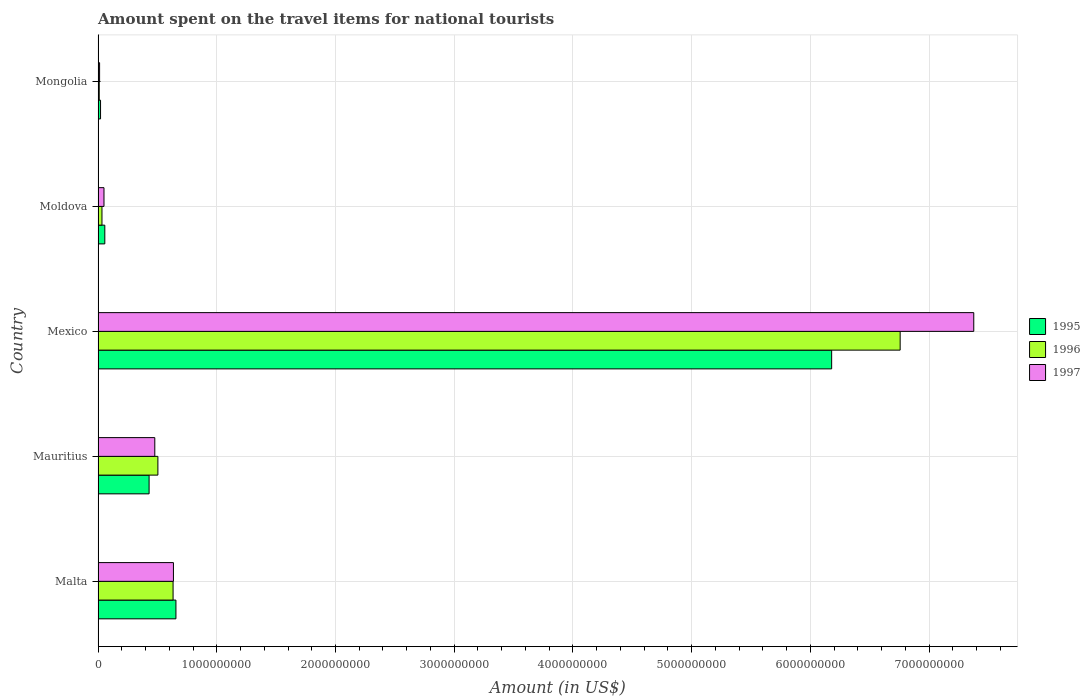How many different coloured bars are there?
Offer a very short reply. 3. How many bars are there on the 5th tick from the top?
Your response must be concise. 3. How many bars are there on the 4th tick from the bottom?
Ensure brevity in your answer.  3. In how many cases, is the number of bars for a given country not equal to the number of legend labels?
Your answer should be compact. 0. Across all countries, what is the maximum amount spent on the travel items for national tourists in 1996?
Your answer should be very brief. 6.76e+09. Across all countries, what is the minimum amount spent on the travel items for national tourists in 1995?
Your answer should be very brief. 2.10e+07. In which country was the amount spent on the travel items for national tourists in 1996 maximum?
Keep it short and to the point. Mexico. In which country was the amount spent on the travel items for national tourists in 1997 minimum?
Provide a succinct answer. Mongolia. What is the total amount spent on the travel items for national tourists in 1996 in the graph?
Give a very brief answer. 7.94e+09. What is the difference between the amount spent on the travel items for national tourists in 1996 in Mexico and that in Moldova?
Provide a short and direct response. 6.72e+09. What is the difference between the amount spent on the travel items for national tourists in 1995 in Mongolia and the amount spent on the travel items for national tourists in 1997 in Mexico?
Your answer should be compact. -7.36e+09. What is the average amount spent on the travel items for national tourists in 1995 per country?
Provide a succinct answer. 1.47e+09. What is the difference between the amount spent on the travel items for national tourists in 1996 and amount spent on the travel items for national tourists in 1997 in Malta?
Ensure brevity in your answer.  -3.00e+06. What is the ratio of the amount spent on the travel items for national tourists in 1995 in Malta to that in Moldova?
Give a very brief answer. 11.51. Is the amount spent on the travel items for national tourists in 1995 in Mexico less than that in Mongolia?
Provide a succinct answer. No. Is the difference between the amount spent on the travel items for national tourists in 1996 in Mexico and Moldova greater than the difference between the amount spent on the travel items for national tourists in 1997 in Mexico and Moldova?
Offer a very short reply. No. What is the difference between the highest and the second highest amount spent on the travel items for national tourists in 1995?
Offer a very short reply. 5.52e+09. What is the difference between the highest and the lowest amount spent on the travel items for national tourists in 1995?
Your answer should be compact. 6.16e+09. What does the 1st bar from the top in Mauritius represents?
Your answer should be very brief. 1997. What does the 3rd bar from the bottom in Moldova represents?
Offer a very short reply. 1997. Is it the case that in every country, the sum of the amount spent on the travel items for national tourists in 1997 and amount spent on the travel items for national tourists in 1995 is greater than the amount spent on the travel items for national tourists in 1996?
Give a very brief answer. Yes. Are all the bars in the graph horizontal?
Offer a terse response. Yes. What is the difference between two consecutive major ticks on the X-axis?
Keep it short and to the point. 1.00e+09. Does the graph contain grids?
Your response must be concise. Yes. How many legend labels are there?
Your response must be concise. 3. How are the legend labels stacked?
Your response must be concise. Vertical. What is the title of the graph?
Offer a terse response. Amount spent on the travel items for national tourists. What is the label or title of the X-axis?
Your answer should be compact. Amount (in US$). What is the Amount (in US$) in 1995 in Malta?
Keep it short and to the point. 6.56e+08. What is the Amount (in US$) of 1996 in Malta?
Offer a very short reply. 6.32e+08. What is the Amount (in US$) of 1997 in Malta?
Ensure brevity in your answer.  6.35e+08. What is the Amount (in US$) in 1995 in Mauritius?
Offer a terse response. 4.30e+08. What is the Amount (in US$) in 1996 in Mauritius?
Keep it short and to the point. 5.04e+08. What is the Amount (in US$) of 1997 in Mauritius?
Your response must be concise. 4.78e+08. What is the Amount (in US$) of 1995 in Mexico?
Keep it short and to the point. 6.18e+09. What is the Amount (in US$) in 1996 in Mexico?
Provide a succinct answer. 6.76e+09. What is the Amount (in US$) in 1997 in Mexico?
Provide a short and direct response. 7.38e+09. What is the Amount (in US$) of 1995 in Moldova?
Your answer should be very brief. 5.70e+07. What is the Amount (in US$) of 1996 in Moldova?
Ensure brevity in your answer.  3.30e+07. What is the Amount (in US$) of 1997 in Moldova?
Your answer should be very brief. 5.00e+07. What is the Amount (in US$) of 1995 in Mongolia?
Your response must be concise. 2.10e+07. What is the Amount (in US$) of 1997 in Mongolia?
Ensure brevity in your answer.  1.30e+07. Across all countries, what is the maximum Amount (in US$) in 1995?
Provide a short and direct response. 6.18e+09. Across all countries, what is the maximum Amount (in US$) of 1996?
Offer a terse response. 6.76e+09. Across all countries, what is the maximum Amount (in US$) of 1997?
Ensure brevity in your answer.  7.38e+09. Across all countries, what is the minimum Amount (in US$) of 1995?
Your answer should be compact. 2.10e+07. Across all countries, what is the minimum Amount (in US$) of 1996?
Your response must be concise. 1.00e+07. Across all countries, what is the minimum Amount (in US$) in 1997?
Offer a very short reply. 1.30e+07. What is the total Amount (in US$) in 1995 in the graph?
Keep it short and to the point. 7.34e+09. What is the total Amount (in US$) in 1996 in the graph?
Provide a succinct answer. 7.94e+09. What is the total Amount (in US$) in 1997 in the graph?
Give a very brief answer. 8.55e+09. What is the difference between the Amount (in US$) of 1995 in Malta and that in Mauritius?
Make the answer very short. 2.26e+08. What is the difference between the Amount (in US$) in 1996 in Malta and that in Mauritius?
Your response must be concise. 1.28e+08. What is the difference between the Amount (in US$) in 1997 in Malta and that in Mauritius?
Provide a short and direct response. 1.57e+08. What is the difference between the Amount (in US$) of 1995 in Malta and that in Mexico?
Keep it short and to the point. -5.52e+09. What is the difference between the Amount (in US$) of 1996 in Malta and that in Mexico?
Give a very brief answer. -6.12e+09. What is the difference between the Amount (in US$) of 1997 in Malta and that in Mexico?
Provide a succinct answer. -6.74e+09. What is the difference between the Amount (in US$) of 1995 in Malta and that in Moldova?
Provide a short and direct response. 5.99e+08. What is the difference between the Amount (in US$) of 1996 in Malta and that in Moldova?
Keep it short and to the point. 5.99e+08. What is the difference between the Amount (in US$) of 1997 in Malta and that in Moldova?
Offer a very short reply. 5.85e+08. What is the difference between the Amount (in US$) of 1995 in Malta and that in Mongolia?
Give a very brief answer. 6.35e+08. What is the difference between the Amount (in US$) of 1996 in Malta and that in Mongolia?
Your answer should be very brief. 6.22e+08. What is the difference between the Amount (in US$) in 1997 in Malta and that in Mongolia?
Offer a very short reply. 6.22e+08. What is the difference between the Amount (in US$) of 1995 in Mauritius and that in Mexico?
Give a very brief answer. -5.75e+09. What is the difference between the Amount (in US$) in 1996 in Mauritius and that in Mexico?
Your answer should be very brief. -6.25e+09. What is the difference between the Amount (in US$) of 1997 in Mauritius and that in Mexico?
Your answer should be very brief. -6.90e+09. What is the difference between the Amount (in US$) in 1995 in Mauritius and that in Moldova?
Make the answer very short. 3.73e+08. What is the difference between the Amount (in US$) of 1996 in Mauritius and that in Moldova?
Give a very brief answer. 4.71e+08. What is the difference between the Amount (in US$) of 1997 in Mauritius and that in Moldova?
Provide a succinct answer. 4.28e+08. What is the difference between the Amount (in US$) in 1995 in Mauritius and that in Mongolia?
Your answer should be compact. 4.09e+08. What is the difference between the Amount (in US$) in 1996 in Mauritius and that in Mongolia?
Offer a terse response. 4.94e+08. What is the difference between the Amount (in US$) of 1997 in Mauritius and that in Mongolia?
Keep it short and to the point. 4.65e+08. What is the difference between the Amount (in US$) of 1995 in Mexico and that in Moldova?
Provide a short and direct response. 6.12e+09. What is the difference between the Amount (in US$) of 1996 in Mexico and that in Moldova?
Ensure brevity in your answer.  6.72e+09. What is the difference between the Amount (in US$) in 1997 in Mexico and that in Moldova?
Offer a very short reply. 7.33e+09. What is the difference between the Amount (in US$) of 1995 in Mexico and that in Mongolia?
Provide a short and direct response. 6.16e+09. What is the difference between the Amount (in US$) of 1996 in Mexico and that in Mongolia?
Your response must be concise. 6.75e+09. What is the difference between the Amount (in US$) in 1997 in Mexico and that in Mongolia?
Offer a very short reply. 7.36e+09. What is the difference between the Amount (in US$) in 1995 in Moldova and that in Mongolia?
Offer a very short reply. 3.60e+07. What is the difference between the Amount (in US$) in 1996 in Moldova and that in Mongolia?
Offer a very short reply. 2.30e+07. What is the difference between the Amount (in US$) of 1997 in Moldova and that in Mongolia?
Ensure brevity in your answer.  3.70e+07. What is the difference between the Amount (in US$) in 1995 in Malta and the Amount (in US$) in 1996 in Mauritius?
Ensure brevity in your answer.  1.52e+08. What is the difference between the Amount (in US$) in 1995 in Malta and the Amount (in US$) in 1997 in Mauritius?
Your answer should be very brief. 1.78e+08. What is the difference between the Amount (in US$) in 1996 in Malta and the Amount (in US$) in 1997 in Mauritius?
Give a very brief answer. 1.54e+08. What is the difference between the Amount (in US$) of 1995 in Malta and the Amount (in US$) of 1996 in Mexico?
Provide a short and direct response. -6.10e+09. What is the difference between the Amount (in US$) in 1995 in Malta and the Amount (in US$) in 1997 in Mexico?
Offer a very short reply. -6.72e+09. What is the difference between the Amount (in US$) of 1996 in Malta and the Amount (in US$) of 1997 in Mexico?
Make the answer very short. -6.74e+09. What is the difference between the Amount (in US$) in 1995 in Malta and the Amount (in US$) in 1996 in Moldova?
Give a very brief answer. 6.23e+08. What is the difference between the Amount (in US$) of 1995 in Malta and the Amount (in US$) of 1997 in Moldova?
Your answer should be compact. 6.06e+08. What is the difference between the Amount (in US$) in 1996 in Malta and the Amount (in US$) in 1997 in Moldova?
Give a very brief answer. 5.82e+08. What is the difference between the Amount (in US$) in 1995 in Malta and the Amount (in US$) in 1996 in Mongolia?
Offer a very short reply. 6.46e+08. What is the difference between the Amount (in US$) of 1995 in Malta and the Amount (in US$) of 1997 in Mongolia?
Keep it short and to the point. 6.43e+08. What is the difference between the Amount (in US$) of 1996 in Malta and the Amount (in US$) of 1997 in Mongolia?
Make the answer very short. 6.19e+08. What is the difference between the Amount (in US$) of 1995 in Mauritius and the Amount (in US$) of 1996 in Mexico?
Give a very brief answer. -6.33e+09. What is the difference between the Amount (in US$) of 1995 in Mauritius and the Amount (in US$) of 1997 in Mexico?
Offer a terse response. -6.95e+09. What is the difference between the Amount (in US$) in 1996 in Mauritius and the Amount (in US$) in 1997 in Mexico?
Your answer should be compact. -6.87e+09. What is the difference between the Amount (in US$) of 1995 in Mauritius and the Amount (in US$) of 1996 in Moldova?
Your answer should be compact. 3.97e+08. What is the difference between the Amount (in US$) in 1995 in Mauritius and the Amount (in US$) in 1997 in Moldova?
Your answer should be compact. 3.80e+08. What is the difference between the Amount (in US$) in 1996 in Mauritius and the Amount (in US$) in 1997 in Moldova?
Keep it short and to the point. 4.54e+08. What is the difference between the Amount (in US$) of 1995 in Mauritius and the Amount (in US$) of 1996 in Mongolia?
Keep it short and to the point. 4.20e+08. What is the difference between the Amount (in US$) of 1995 in Mauritius and the Amount (in US$) of 1997 in Mongolia?
Your answer should be compact. 4.17e+08. What is the difference between the Amount (in US$) in 1996 in Mauritius and the Amount (in US$) in 1997 in Mongolia?
Your answer should be very brief. 4.91e+08. What is the difference between the Amount (in US$) of 1995 in Mexico and the Amount (in US$) of 1996 in Moldova?
Make the answer very short. 6.15e+09. What is the difference between the Amount (in US$) of 1995 in Mexico and the Amount (in US$) of 1997 in Moldova?
Ensure brevity in your answer.  6.13e+09. What is the difference between the Amount (in US$) of 1996 in Mexico and the Amount (in US$) of 1997 in Moldova?
Your answer should be compact. 6.71e+09. What is the difference between the Amount (in US$) in 1995 in Mexico and the Amount (in US$) in 1996 in Mongolia?
Your answer should be compact. 6.17e+09. What is the difference between the Amount (in US$) in 1995 in Mexico and the Amount (in US$) in 1997 in Mongolia?
Give a very brief answer. 6.17e+09. What is the difference between the Amount (in US$) of 1996 in Mexico and the Amount (in US$) of 1997 in Mongolia?
Offer a terse response. 6.74e+09. What is the difference between the Amount (in US$) in 1995 in Moldova and the Amount (in US$) in 1996 in Mongolia?
Make the answer very short. 4.70e+07. What is the difference between the Amount (in US$) of 1995 in Moldova and the Amount (in US$) of 1997 in Mongolia?
Keep it short and to the point. 4.40e+07. What is the difference between the Amount (in US$) in 1996 in Moldova and the Amount (in US$) in 1997 in Mongolia?
Make the answer very short. 2.00e+07. What is the average Amount (in US$) of 1995 per country?
Keep it short and to the point. 1.47e+09. What is the average Amount (in US$) of 1996 per country?
Keep it short and to the point. 1.59e+09. What is the average Amount (in US$) of 1997 per country?
Provide a succinct answer. 1.71e+09. What is the difference between the Amount (in US$) of 1995 and Amount (in US$) of 1996 in Malta?
Offer a very short reply. 2.40e+07. What is the difference between the Amount (in US$) of 1995 and Amount (in US$) of 1997 in Malta?
Give a very brief answer. 2.10e+07. What is the difference between the Amount (in US$) of 1996 and Amount (in US$) of 1997 in Malta?
Offer a very short reply. -3.00e+06. What is the difference between the Amount (in US$) in 1995 and Amount (in US$) in 1996 in Mauritius?
Make the answer very short. -7.40e+07. What is the difference between the Amount (in US$) of 1995 and Amount (in US$) of 1997 in Mauritius?
Your answer should be very brief. -4.80e+07. What is the difference between the Amount (in US$) in 1996 and Amount (in US$) in 1997 in Mauritius?
Provide a short and direct response. 2.60e+07. What is the difference between the Amount (in US$) in 1995 and Amount (in US$) in 1996 in Mexico?
Your response must be concise. -5.77e+08. What is the difference between the Amount (in US$) in 1995 and Amount (in US$) in 1997 in Mexico?
Your response must be concise. -1.20e+09. What is the difference between the Amount (in US$) of 1996 and Amount (in US$) of 1997 in Mexico?
Offer a very short reply. -6.20e+08. What is the difference between the Amount (in US$) of 1995 and Amount (in US$) of 1996 in Moldova?
Make the answer very short. 2.40e+07. What is the difference between the Amount (in US$) of 1996 and Amount (in US$) of 1997 in Moldova?
Ensure brevity in your answer.  -1.70e+07. What is the difference between the Amount (in US$) of 1995 and Amount (in US$) of 1996 in Mongolia?
Your answer should be compact. 1.10e+07. What is the difference between the Amount (in US$) in 1996 and Amount (in US$) in 1997 in Mongolia?
Provide a succinct answer. -3.00e+06. What is the ratio of the Amount (in US$) of 1995 in Malta to that in Mauritius?
Make the answer very short. 1.53. What is the ratio of the Amount (in US$) in 1996 in Malta to that in Mauritius?
Your response must be concise. 1.25. What is the ratio of the Amount (in US$) in 1997 in Malta to that in Mauritius?
Provide a short and direct response. 1.33. What is the ratio of the Amount (in US$) in 1995 in Malta to that in Mexico?
Ensure brevity in your answer.  0.11. What is the ratio of the Amount (in US$) in 1996 in Malta to that in Mexico?
Keep it short and to the point. 0.09. What is the ratio of the Amount (in US$) of 1997 in Malta to that in Mexico?
Your answer should be compact. 0.09. What is the ratio of the Amount (in US$) of 1995 in Malta to that in Moldova?
Your answer should be very brief. 11.51. What is the ratio of the Amount (in US$) of 1996 in Malta to that in Moldova?
Give a very brief answer. 19.15. What is the ratio of the Amount (in US$) in 1995 in Malta to that in Mongolia?
Your answer should be very brief. 31.24. What is the ratio of the Amount (in US$) of 1996 in Malta to that in Mongolia?
Your response must be concise. 63.2. What is the ratio of the Amount (in US$) in 1997 in Malta to that in Mongolia?
Ensure brevity in your answer.  48.85. What is the ratio of the Amount (in US$) of 1995 in Mauritius to that in Mexico?
Offer a terse response. 0.07. What is the ratio of the Amount (in US$) of 1996 in Mauritius to that in Mexico?
Provide a short and direct response. 0.07. What is the ratio of the Amount (in US$) in 1997 in Mauritius to that in Mexico?
Your response must be concise. 0.06. What is the ratio of the Amount (in US$) in 1995 in Mauritius to that in Moldova?
Provide a succinct answer. 7.54. What is the ratio of the Amount (in US$) in 1996 in Mauritius to that in Moldova?
Provide a short and direct response. 15.27. What is the ratio of the Amount (in US$) in 1997 in Mauritius to that in Moldova?
Your response must be concise. 9.56. What is the ratio of the Amount (in US$) of 1995 in Mauritius to that in Mongolia?
Your response must be concise. 20.48. What is the ratio of the Amount (in US$) of 1996 in Mauritius to that in Mongolia?
Provide a succinct answer. 50.4. What is the ratio of the Amount (in US$) in 1997 in Mauritius to that in Mongolia?
Provide a succinct answer. 36.77. What is the ratio of the Amount (in US$) in 1995 in Mexico to that in Moldova?
Provide a succinct answer. 108.4. What is the ratio of the Amount (in US$) in 1996 in Mexico to that in Moldova?
Make the answer very short. 204.73. What is the ratio of the Amount (in US$) of 1997 in Mexico to that in Moldova?
Provide a succinct answer. 147.52. What is the ratio of the Amount (in US$) of 1995 in Mexico to that in Mongolia?
Offer a very short reply. 294.24. What is the ratio of the Amount (in US$) in 1996 in Mexico to that in Mongolia?
Make the answer very short. 675.6. What is the ratio of the Amount (in US$) in 1997 in Mexico to that in Mongolia?
Give a very brief answer. 567.38. What is the ratio of the Amount (in US$) in 1995 in Moldova to that in Mongolia?
Provide a short and direct response. 2.71. What is the ratio of the Amount (in US$) in 1997 in Moldova to that in Mongolia?
Your response must be concise. 3.85. What is the difference between the highest and the second highest Amount (in US$) in 1995?
Your answer should be compact. 5.52e+09. What is the difference between the highest and the second highest Amount (in US$) in 1996?
Provide a short and direct response. 6.12e+09. What is the difference between the highest and the second highest Amount (in US$) in 1997?
Your response must be concise. 6.74e+09. What is the difference between the highest and the lowest Amount (in US$) in 1995?
Ensure brevity in your answer.  6.16e+09. What is the difference between the highest and the lowest Amount (in US$) in 1996?
Offer a terse response. 6.75e+09. What is the difference between the highest and the lowest Amount (in US$) of 1997?
Keep it short and to the point. 7.36e+09. 